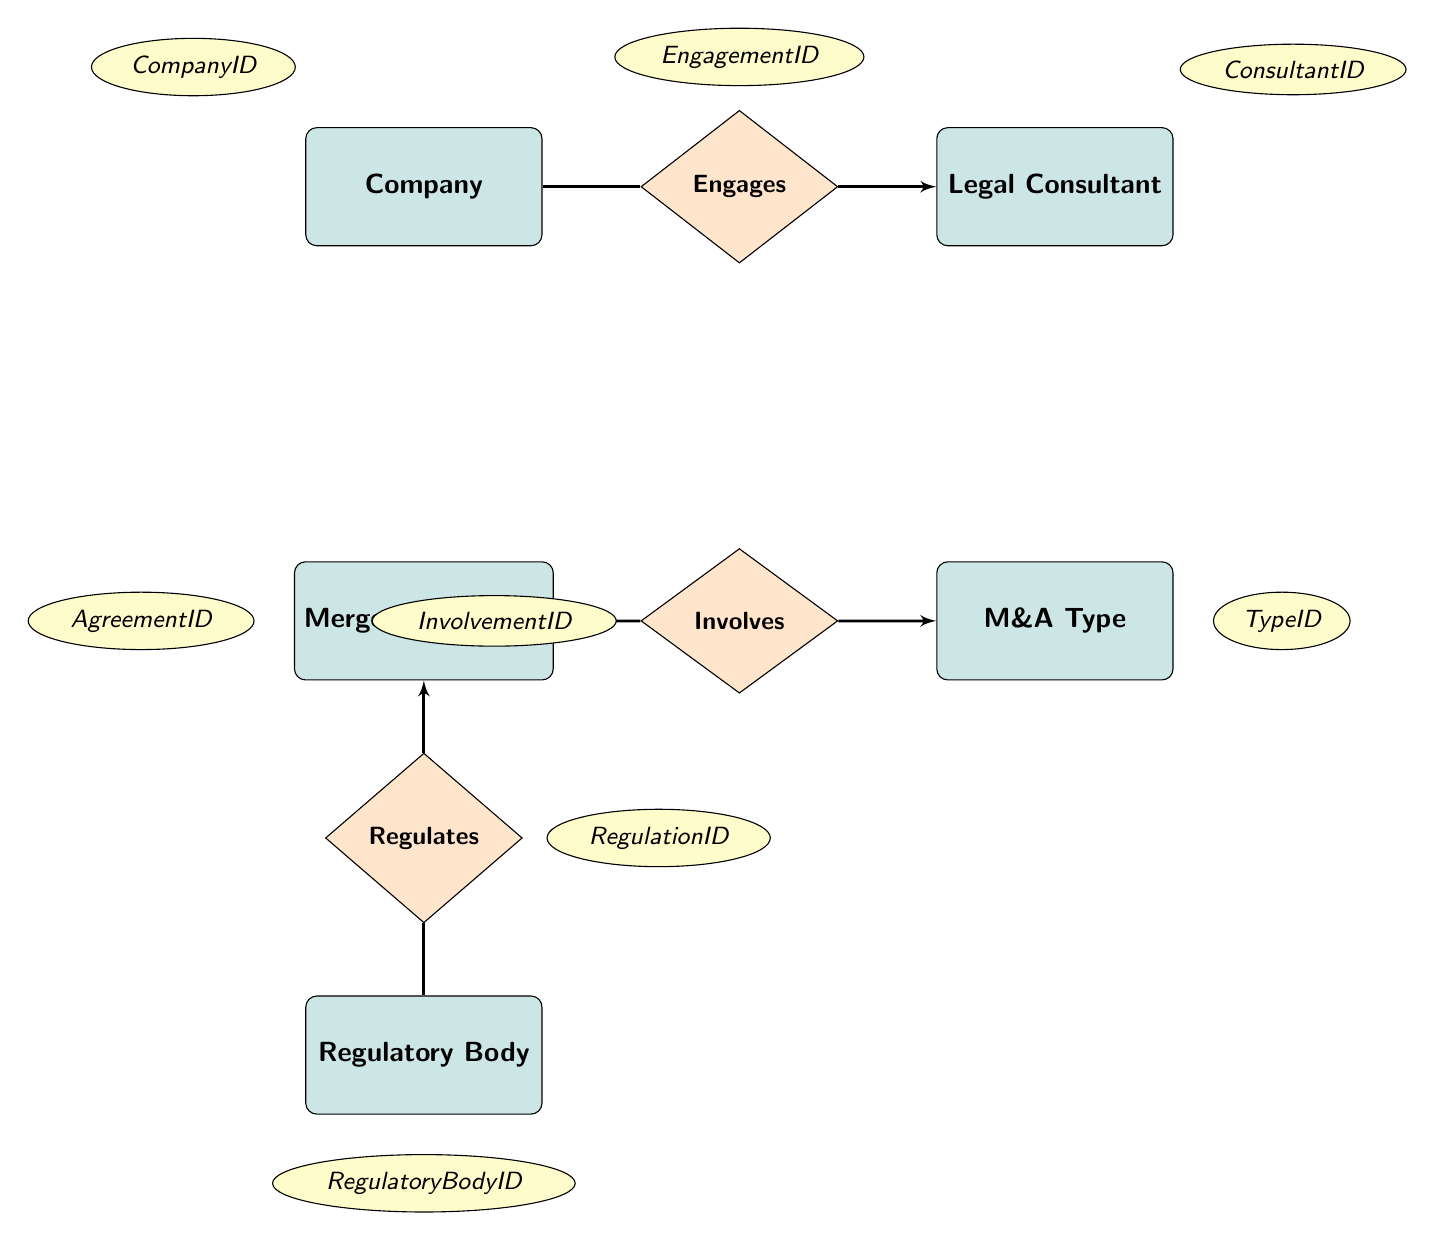What entities are present in the diagram? The entities listed in the diagram include Company, Legal Consultant, Merger Agreement, M&A Type, and Regulatory Body.
Answer: Company, Legal Consultant, Merger Agreement, M&A Type, Regulatory Body How many relationships are shown in the diagram? The diagram outlines three relationships: Engages, Involves, and Regulates.
Answer: 3 What is the relationship between Company and Legal Consultant? The relationship shown in the diagram between Company and Legal Consultant is labeled as Engages.
Answer: Engages What is the attribute of Merger Agreement that identifies it uniquely? The unique identifier for the Merger Agreement is the AgreementID, which is listed as an attribute in the diagram.
Answer: AgreementID What is the type of relationship that connects Merger Agreement and M&A Type? The relationship that connects Merger Agreement and M&A Type is labeled as Involves.
Answer: Involves What attributes characterize the Legal Consultant entity? The attributes for the Legal Consultant entity include ConsultantID, Name, and Firm.
Answer: ConsultantID, Name, Firm What does the Regulatory Body do in relation to the Merger Agreement? The Regulatory Body Regulates the Merger Agreement, establishing a compliance relationship according to the diagram.
Answer: Regulates How is the M&A Type entity related to the Merger Agreement? The M&A Type is related to the Merger Agreement through the Involves relationship, meaning that each agreement can correspond to specific types of mergers or acquisitions.
Answer: Involves What attributes are associated with the Engages relationship? The Engages relationship has attributes including EngagementID, StartDate, and EndDate, which are used to track the engagement of legal consultants by companies.
Answer: EngagementID, StartDate, EndDate 